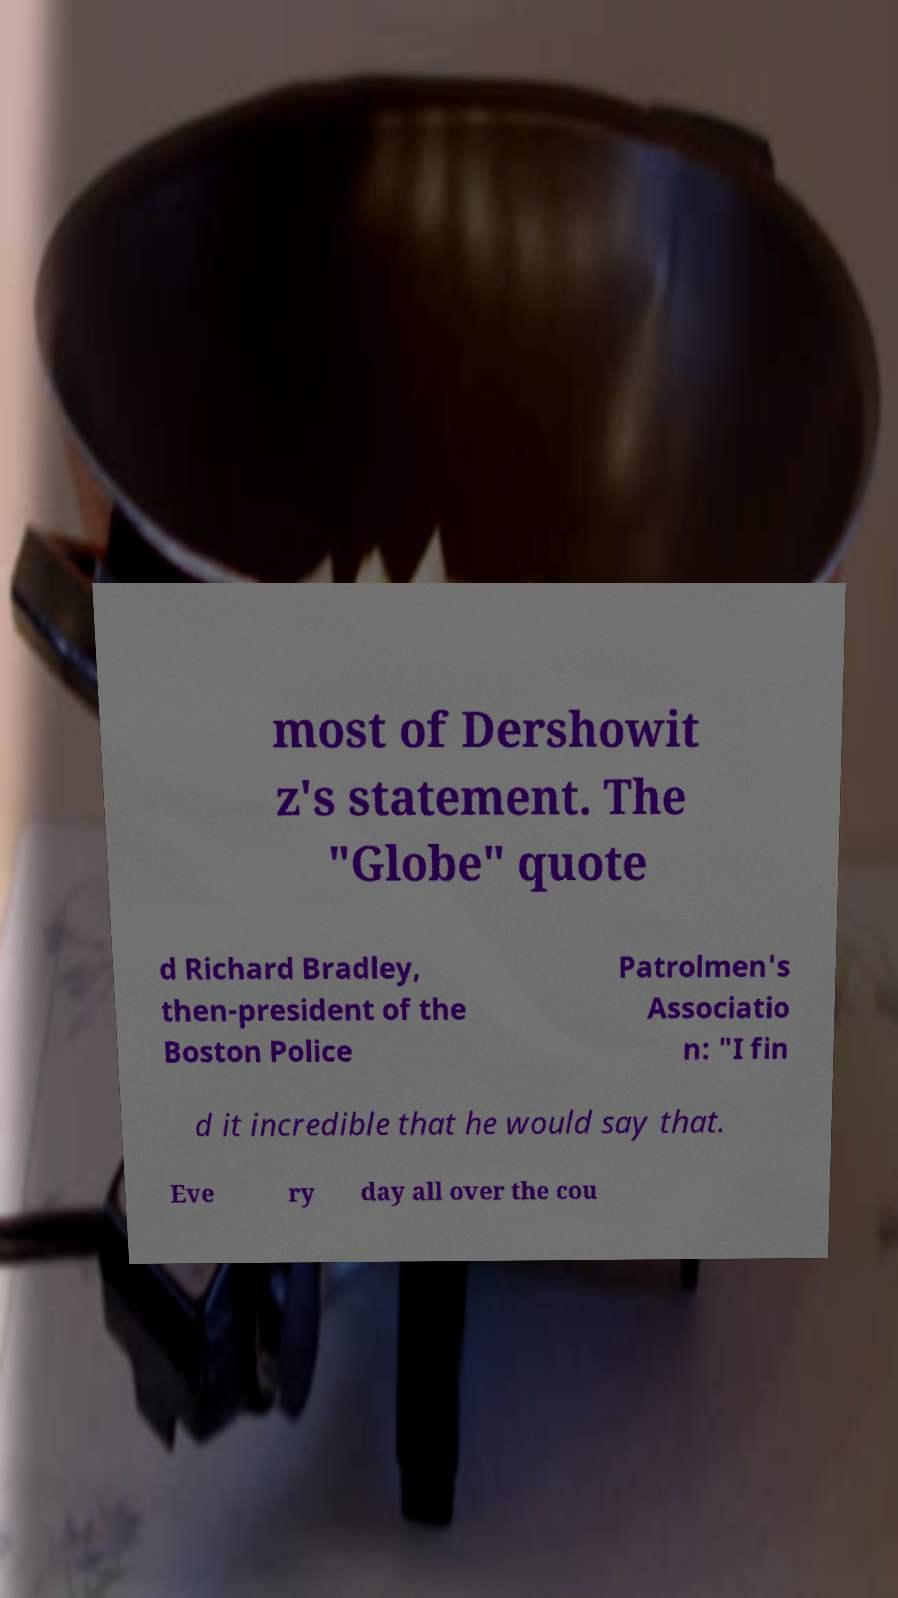I need the written content from this picture converted into text. Can you do that? most of Dershowit z's statement. The "Globe" quote d Richard Bradley, then-president of the Boston Police Patrolmen's Associatio n: "I fin d it incredible that he would say that. Eve ry day all over the cou 